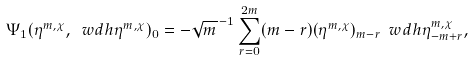<formula> <loc_0><loc_0><loc_500><loc_500>\Psi _ { 1 } ( \eta ^ { m , \chi } , \ w d h { \eta } ^ { m , \chi } ) _ { 0 } = - \sqrt { m } ^ { \, - 1 } \sum _ { r = 0 } ^ { 2 m } ( m - r ) ( \eta ^ { m , \chi } ) _ { m - r } \ w d h { \eta } ^ { m , \chi } _ { - m + r } ,</formula> 